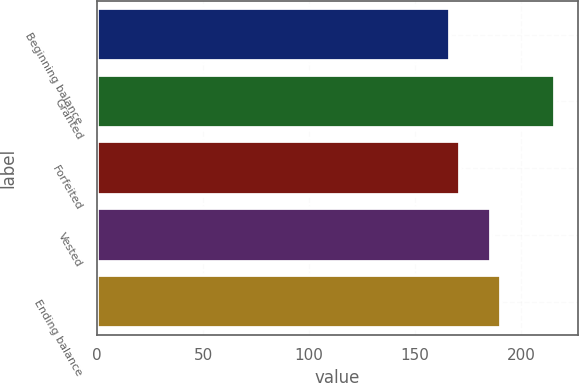Convert chart. <chart><loc_0><loc_0><loc_500><loc_500><bar_chart><fcel>Beginning balance<fcel>Granted<fcel>Forfeited<fcel>Vested<fcel>Ending balance<nl><fcel>166.3<fcel>216.05<fcel>171.28<fcel>185.62<fcel>190.59<nl></chart> 